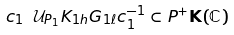Convert formula to latex. <formula><loc_0><loc_0><loc_500><loc_500>c _ { 1 } \ \mathcal { U } _ { P _ { 1 } } K _ { 1 h } G _ { 1 \ell } c _ { 1 } ^ { - 1 } \subset P ^ { + } \mathbf K ( \mathbb { C } )</formula> 